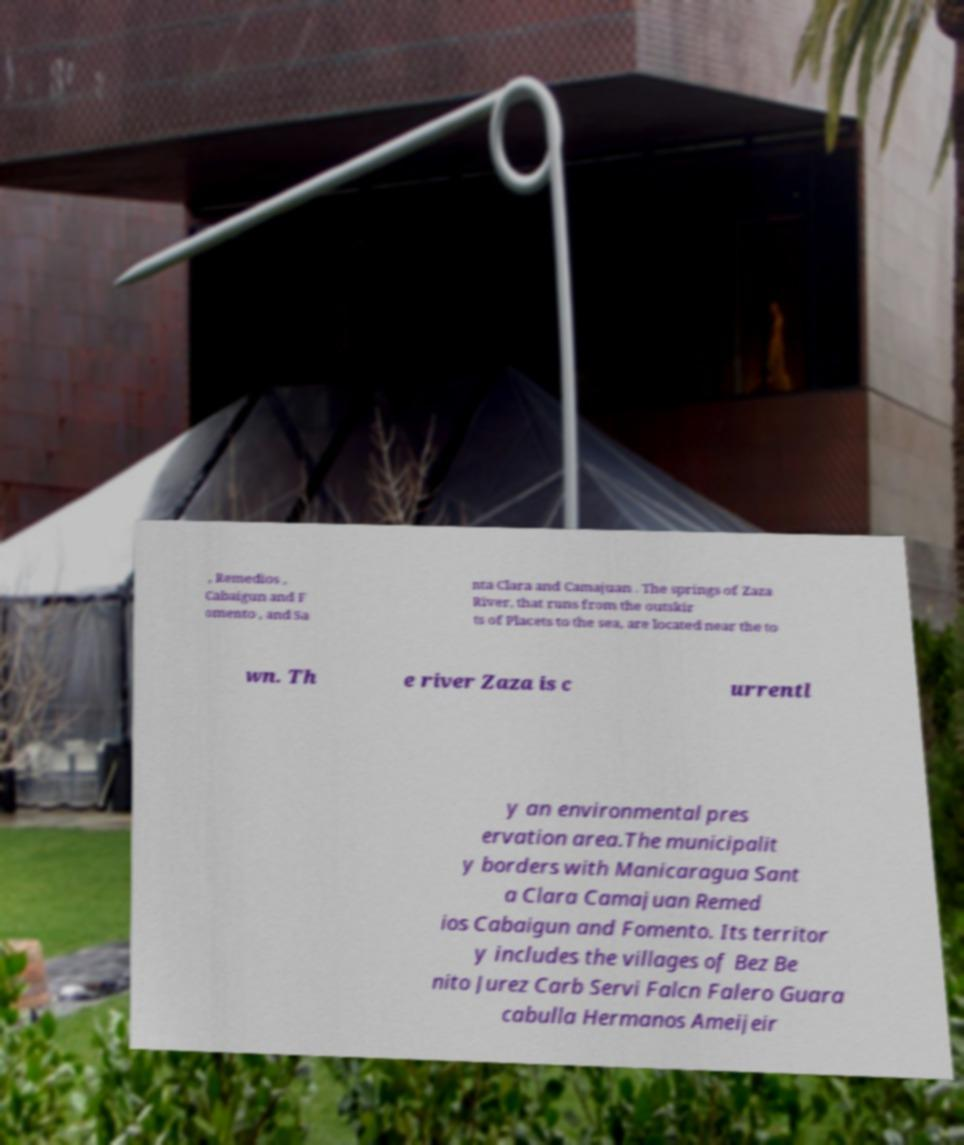Could you assist in decoding the text presented in this image and type it out clearly? , Remedios , Cabaigun and F omento , and Sa nta Clara and Camajuan . The springs of Zaza River, that runs from the outskir ts of Placets to the sea, are located near the to wn. Th e river Zaza is c urrentl y an environmental pres ervation area.The municipalit y borders with Manicaragua Sant a Clara Camajuan Remed ios Cabaigun and Fomento. Its territor y includes the villages of Bez Be nito Jurez Carb Servi Falcn Falero Guara cabulla Hermanos Ameijeir 